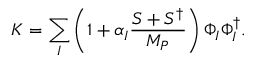<formula> <loc_0><loc_0><loc_500><loc_500>K = \sum _ { I } \left ( 1 + \alpha _ { I } \frac { S + S ^ { \dagger } } { M _ { P } } \right ) \Phi _ { I } \Phi _ { I } ^ { \dagger } .</formula> 